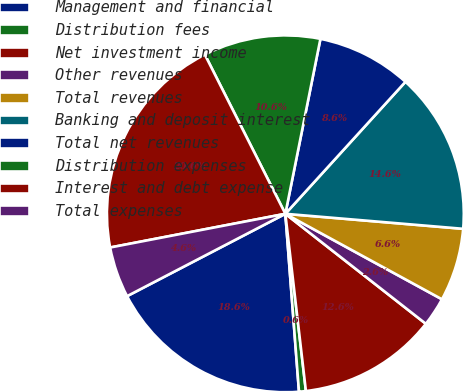Convert chart. <chart><loc_0><loc_0><loc_500><loc_500><pie_chart><fcel>Management and financial<fcel>Distribution fees<fcel>Net investment income<fcel>Other revenues<fcel>Total revenues<fcel>Banking and deposit interest<fcel>Total net revenues<fcel>Distribution expenses<fcel>Interest and debt expense<fcel>Total expenses<nl><fcel>18.58%<fcel>0.62%<fcel>12.59%<fcel>2.62%<fcel>6.61%<fcel>14.59%<fcel>8.6%<fcel>10.6%<fcel>20.57%<fcel>4.61%<nl></chart> 